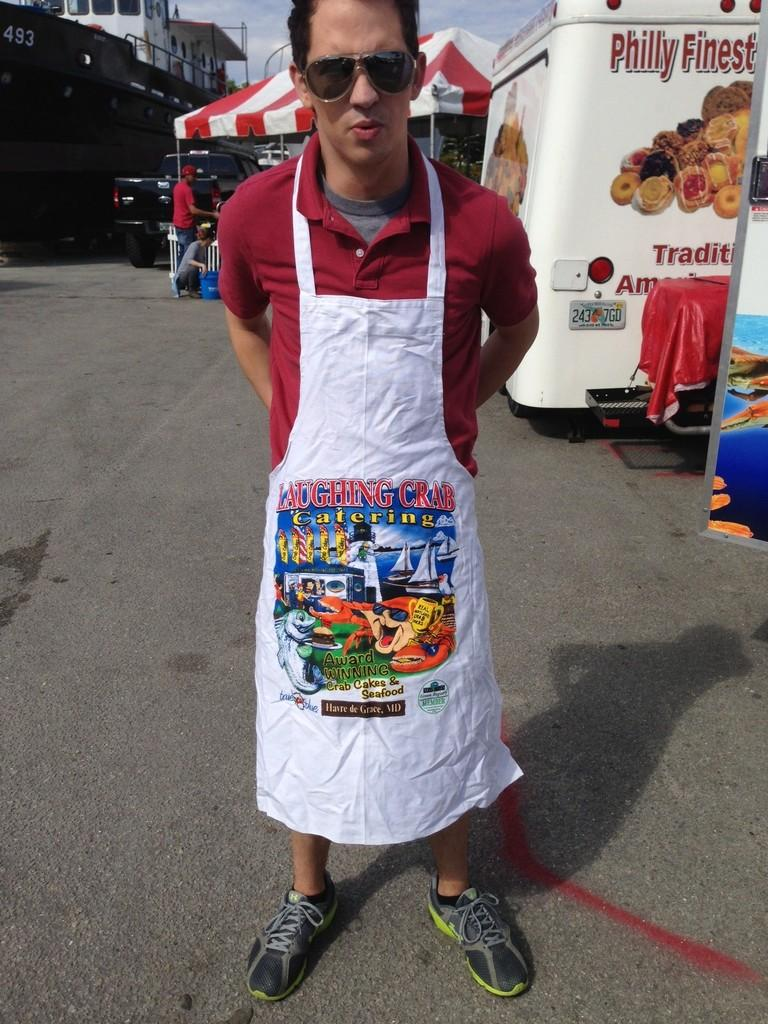<image>
Write a terse but informative summary of the picture. A man stands wearing an apron that says Laughing Crab. 